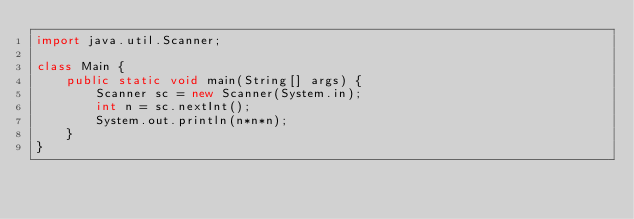<code> <loc_0><loc_0><loc_500><loc_500><_Java_>import java.util.Scanner;
 
class Main {
    public static void main(String[] args) {
        Scanner sc = new Scanner(System.in);
        int n = sc.nextInt();
        System.out.println(n*n*n);
    }
}

</code> 